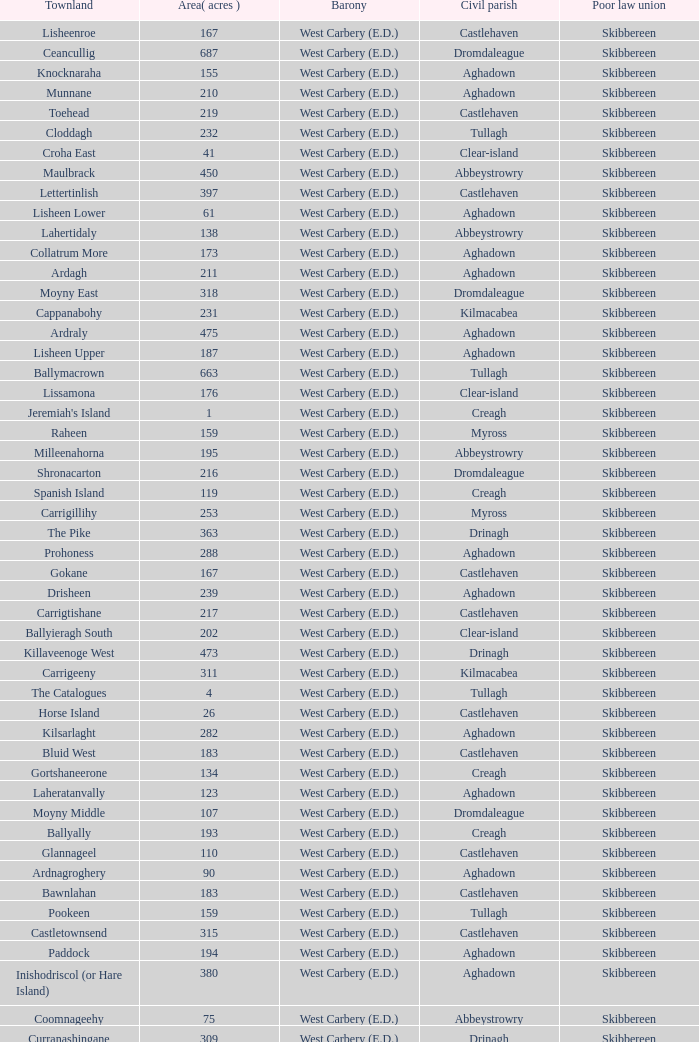What is the greatest area when the Poor Law Union is Skibbereen and the Civil Parish is Tullagh? 796.0. 